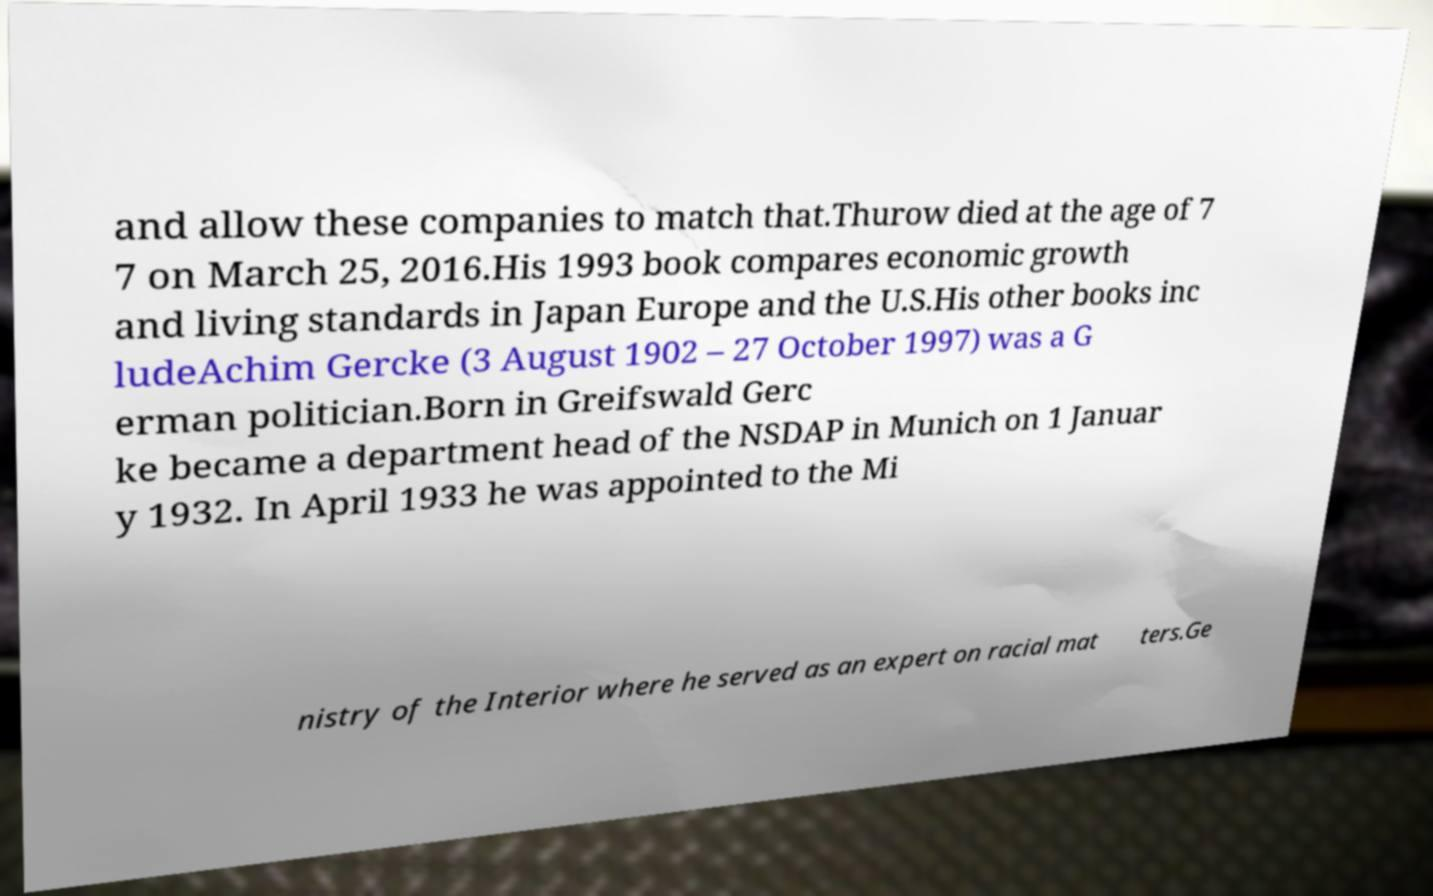Please identify and transcribe the text found in this image. and allow these companies to match that.Thurow died at the age of 7 7 on March 25, 2016.His 1993 book compares economic growth and living standards in Japan Europe and the U.S.His other books inc ludeAchim Gercke (3 August 1902 – 27 October 1997) was a G erman politician.Born in Greifswald Gerc ke became a department head of the NSDAP in Munich on 1 Januar y 1932. In April 1933 he was appointed to the Mi nistry of the Interior where he served as an expert on racial mat ters.Ge 